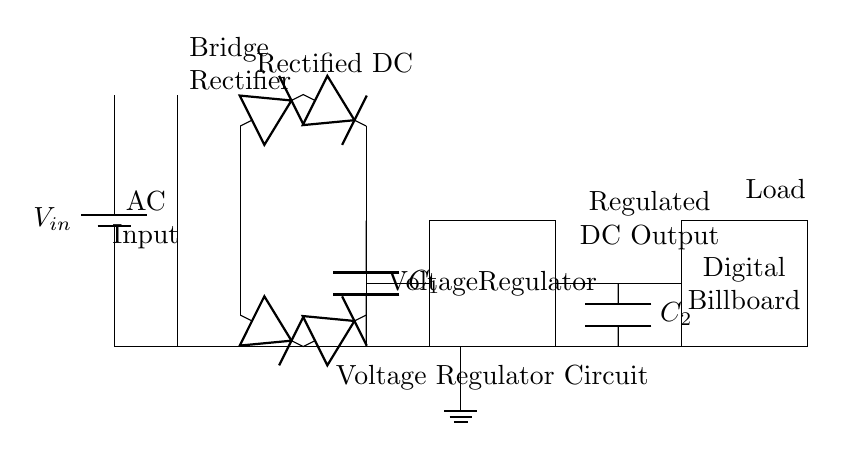What is the input voltage source connected to? The input voltage source, labeled as V_{in}, is connected to a transformer in the circuit diagram. This transformer modifies the voltage before it is rectified.
Answer: Transformer What component smooths the output after rectification? The component that smooths the output after rectification is a capacitor labeled C_1, which is connected in parallel with the rectifier output, acting to reduce voltage fluctuations.
Answer: C_1 How many diodes are in the rectifier bridge? The rectifier bridge is made up of four diodes, two for each half of the AC cycle, allowing for efficient conversion from alternating current to direct current.
Answer: Four What is the role of the voltage regulator in this circuit? The voltage regulator is designed to provide a stable and consistent output voltage from the varying input voltage, ensuring that the digital billboard receives the proper voltage for operation.
Answer: Stable voltage What type of load does this circuit supply power to? The circuit supplies power to a digital billboard, which requires reliable DC voltage for its operation, indicated by the labeled rectangular component in the diagram.
Answer: Digital Billboard What happens to the voltage after the output capacitor? After the output capacitor C_2, the voltage is regulated and stable, which is necessary for the reliable operation of the connected load, ensuring that there are minimal voltage spikes or drops.
Answer: Regulated DC Output 